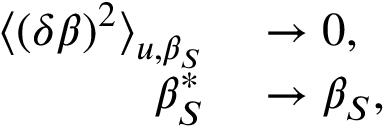<formula> <loc_0><loc_0><loc_500><loc_500>\begin{array} { r l } { \Big < ( \delta \beta ) ^ { 2 } \Big > _ { u , \beta _ { S } } } & \rightarrow 0 , } \\ { \beta _ { S } ^ { * } } & \rightarrow \beta _ { S } , } \end{array}</formula> 